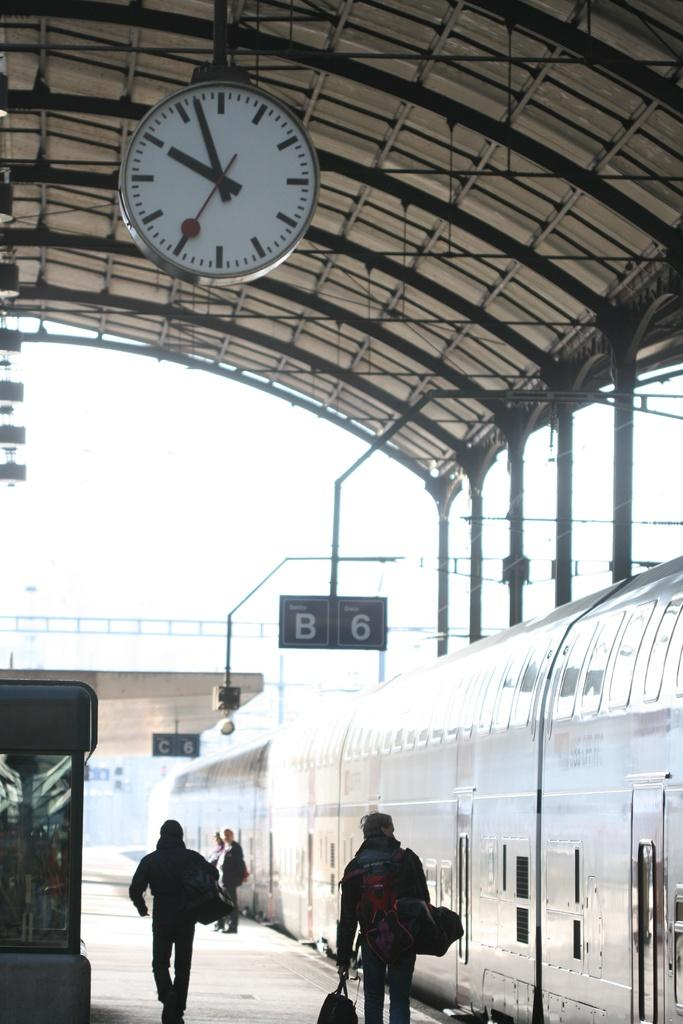Provide a one-sentence caption for the provided image. The letter B can be seen hanging from above with people walking under alongside the train. 